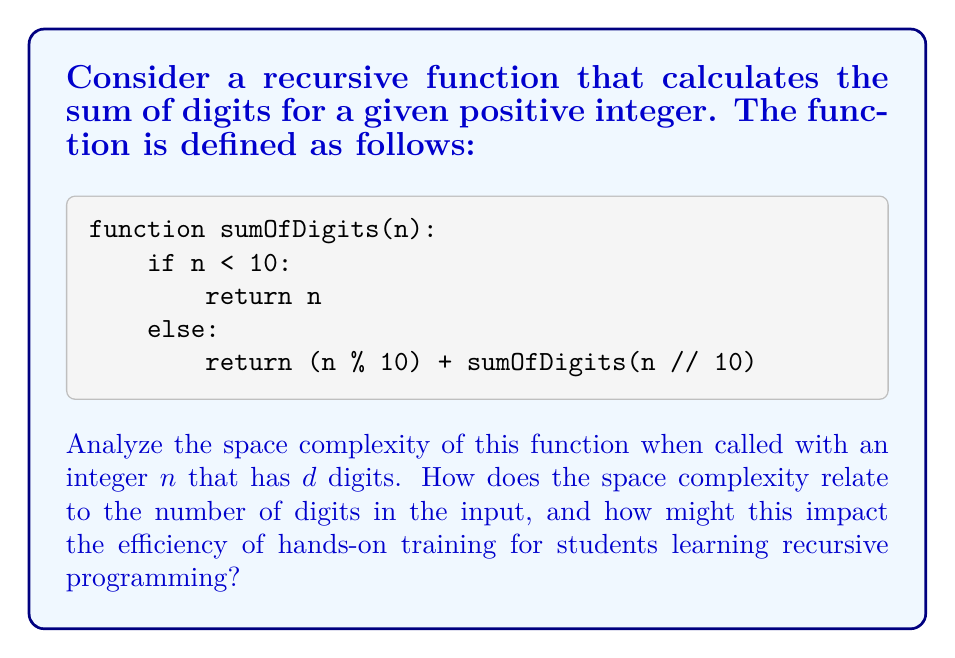Solve this math problem. To analyze the space complexity of this recursive function, we need to consider the amount of memory used by the function calls on the call stack. Let's break it down step-by-step:

1. Base case: When $n < 10$, the function returns immediately without making any recursive calls. This uses constant space.

2. Recursive case: When $n \geq 10$, the function makes a recursive call with $n // 10$ (integer division by 10).

3. Number of recursive calls: For a number with $d$ digits, the function will make $d-1$ recursive calls before reaching the base case. This is because each call reduces the number of digits by 1.

4. Stack frame size: Each recursive call adds a new stack frame to the call stack. The stack frame contains:
   - The parameter $n$
   - The return address
   - Any local variables (in this case, none)

   The size of each stack frame is constant, let's call it $c$.

5. Total space used: The maximum depth of the recursion is $d$, so the total space used on the call stack is $O(d)$.

Space complexity: $O(d)$, where $d$ is the number of digits in the input number $n$.

Relation to input size: Note that $d = \lfloor \log_{10}(n) \rfloor + 1$, so we can also express the space complexity as $O(\log n)$.

Impact on hands-on training:
1. This space complexity demonstrates that the memory usage grows linearly with the number of digits, which is logarithmic with respect to the input number. This is generally considered efficient for most practical purposes.

2. For students learning recursive programming, this example provides a good balance between simplicity and real-world applicability. It shows how a seemingly simple problem can lead to a non-constant space complexity.

3. In hands-on training, students can experiment with different input sizes and observe how the memory usage changes, helping them develop an intuition for space complexity analysis.

4. Understanding this concept is crucial for students who might work on embedded systems or resource-constrained environments where memory usage is a critical factor.

5. This example can be used to introduce the concept of tail recursion optimization, which could potentially reduce the space complexity to O(1) if supported by the programming language and compiler.
Answer: The space complexity of the sumOfDigits function is $O(d)$, where $d$ is the number of digits in the input number $n$. This can also be expressed as $O(\log n)$ since $d = \lfloor \log_{10}(n) \rfloor + 1$. 